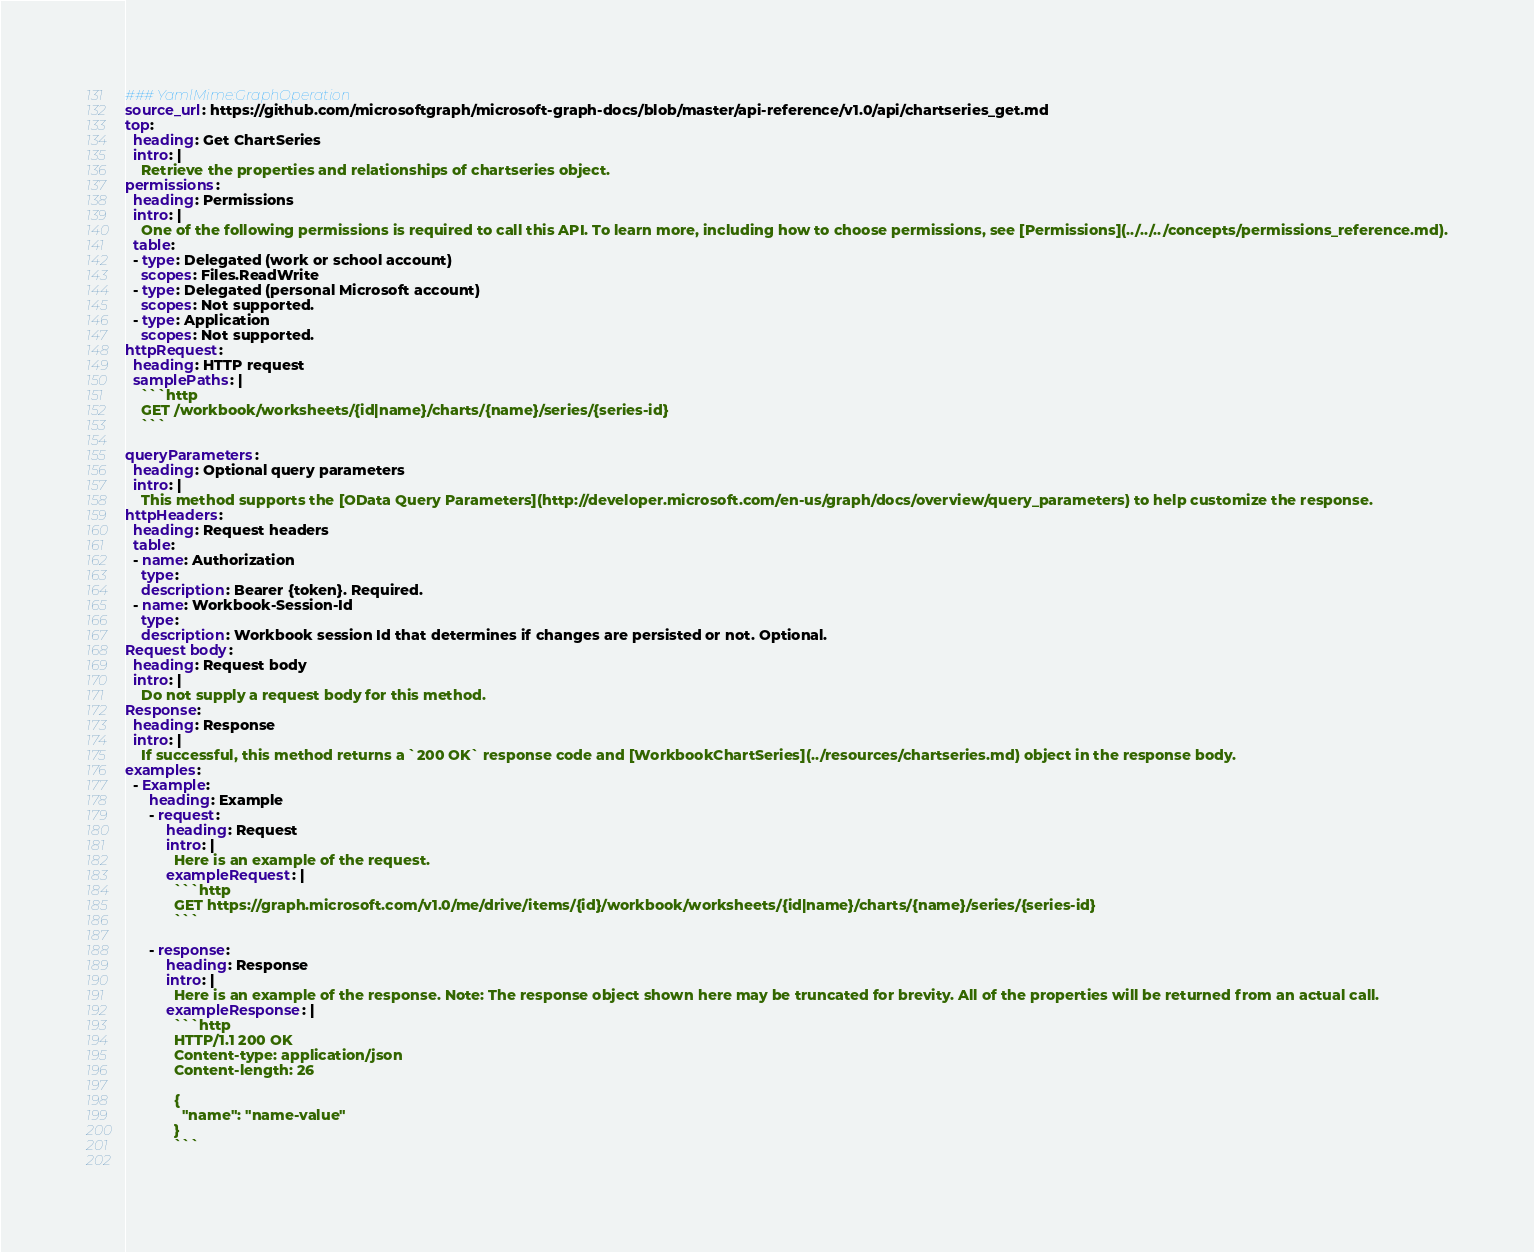<code> <loc_0><loc_0><loc_500><loc_500><_YAML_>### YamlMime:GraphOperation
source_url: https://github.com/microsoftgraph/microsoft-graph-docs/blob/master/api-reference/v1.0/api/chartseries_get.md
top:
  heading: Get ChartSeries
  intro: |
    Retrieve the properties and relationships of chartseries object.
permissions:
  heading: Permissions
  intro: |
    One of the following permissions is required to call this API. To learn more, including how to choose permissions, see [Permissions](../../../concepts/permissions_reference.md).
  table:
  - type: Delegated (work or school account)
    scopes: Files.ReadWrite
  - type: Delegated (personal Microsoft account)
    scopes: Not supported.
  - type: Application
    scopes: Not supported.
httpRequest:
  heading: HTTP request
  samplePaths: |
    ```http
    GET /workbook/worksheets/{id|name}/charts/{name}/series/{series-id}
    ```
    
queryParameters:
  heading: Optional query parameters
  intro: |
    This method supports the [OData Query Parameters](http://developer.microsoft.com/en-us/graph/docs/overview/query_parameters) to help customize the response.
httpHeaders:
  heading: Request headers
  table:
  - name: Authorization
    type: 
    description: Bearer {token}. Required.
  - name: Workbook-Session-Id
    type: 
    description: Workbook session Id that determines if changes are persisted or not. Optional.
Request body:
  heading: Request body
  intro: |
    Do not supply a request body for this method.
Response:
  heading: Response
  intro: |
    If successful, this method returns a `200 OK` response code and [WorkbookChartSeries](../resources/chartseries.md) object in the response body.
examples:
  - Example:
      heading: Example
      - request:
          heading: Request
          intro: |
            Here is an example of the request.
          exampleRequest: |
            ```http
            GET https://graph.microsoft.com/v1.0/me/drive/items/{id}/workbook/worksheets/{id|name}/charts/{name}/series/{series-id}
            ```
            
      - response:
          heading: Response
          intro: |
            Here is an example of the response. Note: The response object shown here may be truncated for brevity. All of the properties will be returned from an actual call.
          exampleResponse: |
            ```http
            HTTP/1.1 200 OK
            Content-type: application/json
            Content-length: 26
            
            {
              "name": "name-value"
            }
            ```
            
</code> 